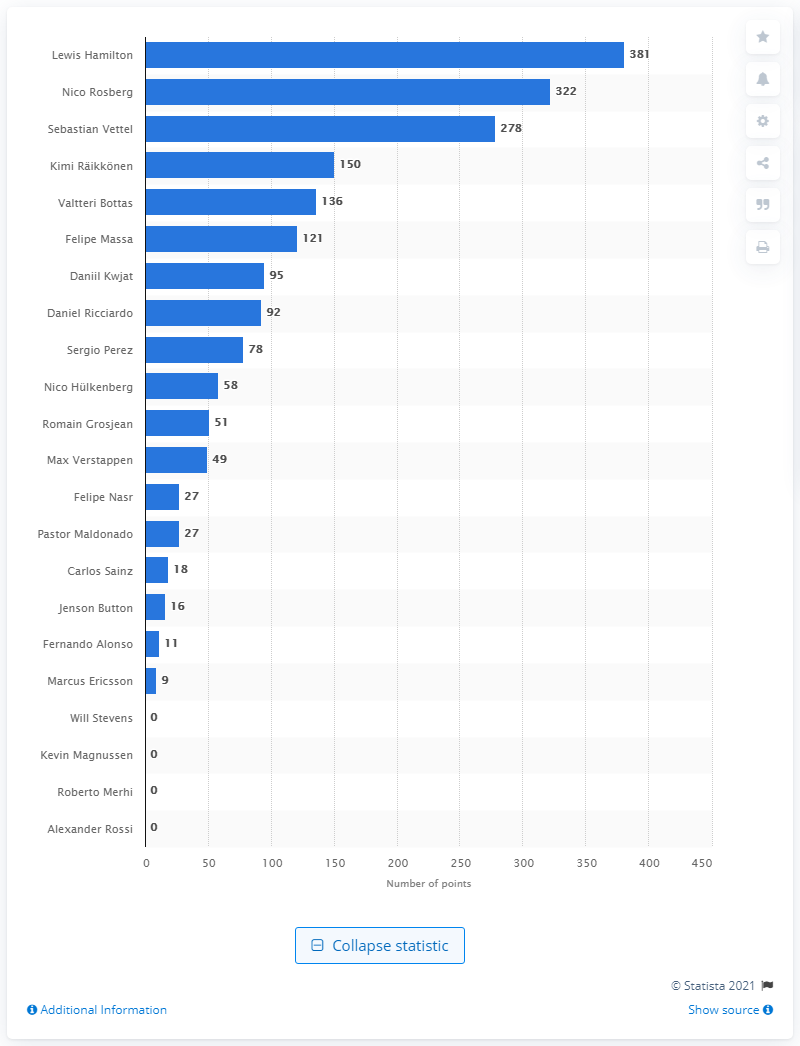Draw attention to some important aspects in this diagram. In the 2015 season, Lewis Hamilton accumulated a total of 381 points, which was the most points he has ever accumulated in a single season. 